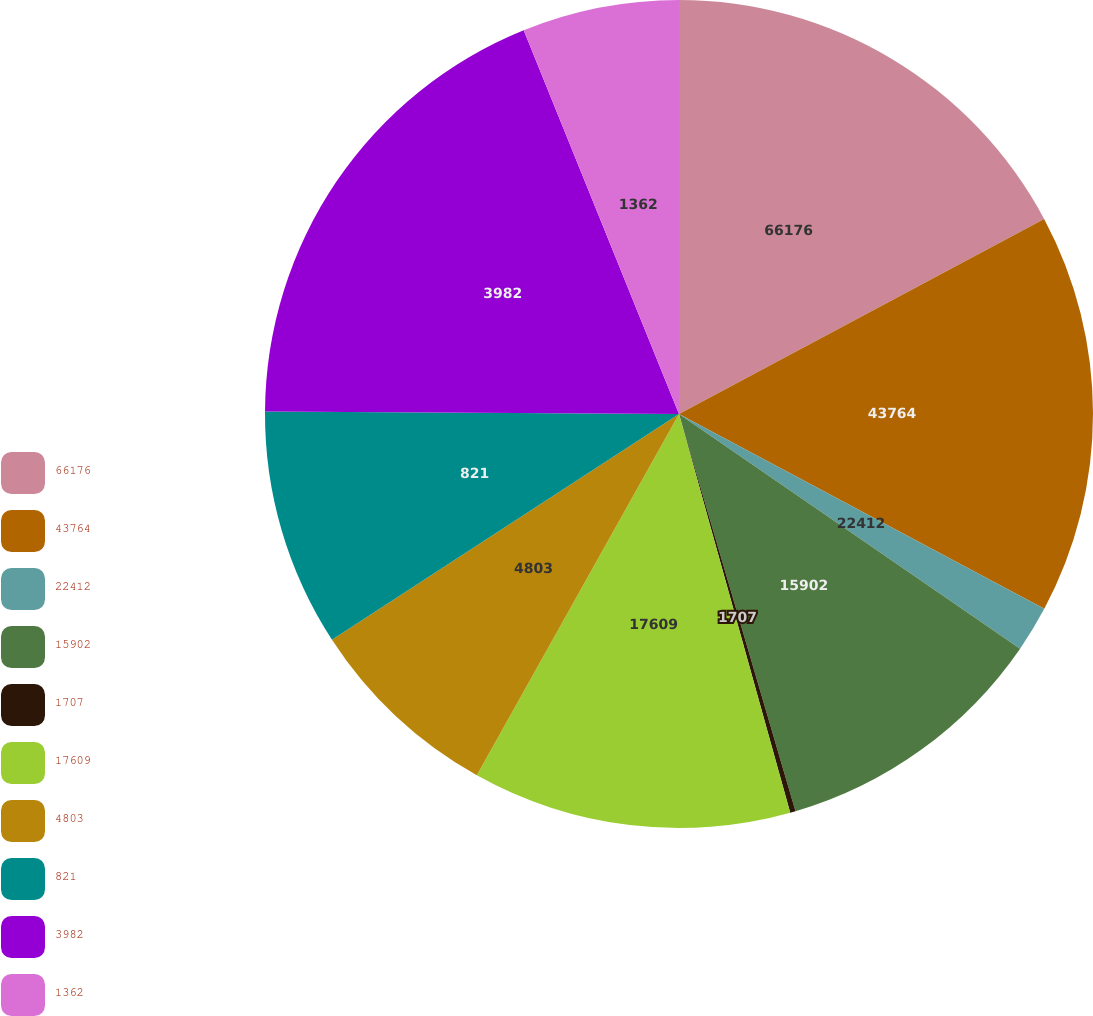<chart> <loc_0><loc_0><loc_500><loc_500><pie_chart><fcel>66176<fcel>43764<fcel>22412<fcel>15902<fcel>1707<fcel>17609<fcel>4803<fcel>821<fcel>3982<fcel>1362<nl><fcel>17.19%<fcel>15.61%<fcel>1.79%<fcel>10.87%<fcel>0.21%<fcel>12.45%<fcel>7.7%<fcel>9.28%<fcel>18.78%<fcel>6.12%<nl></chart> 